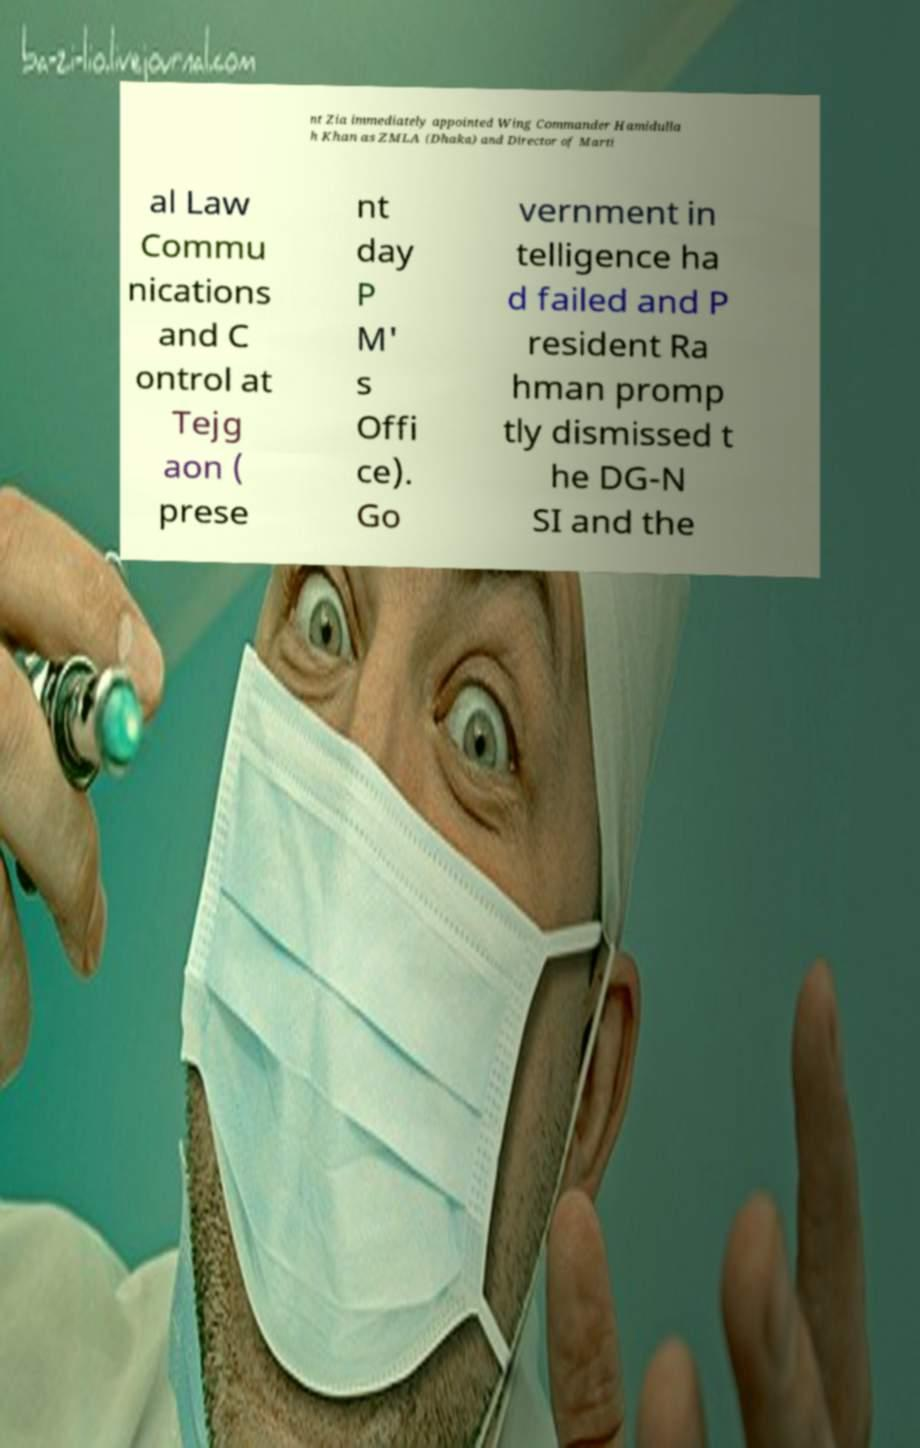Could you extract and type out the text from this image? nt Zia immediately appointed Wing Commander Hamidulla h Khan as ZMLA (Dhaka) and Director of Marti al Law Commu nications and C ontrol at Tejg aon ( prese nt day P M' s Offi ce). Go vernment in telligence ha d failed and P resident Ra hman promp tly dismissed t he DG-N SI and the 